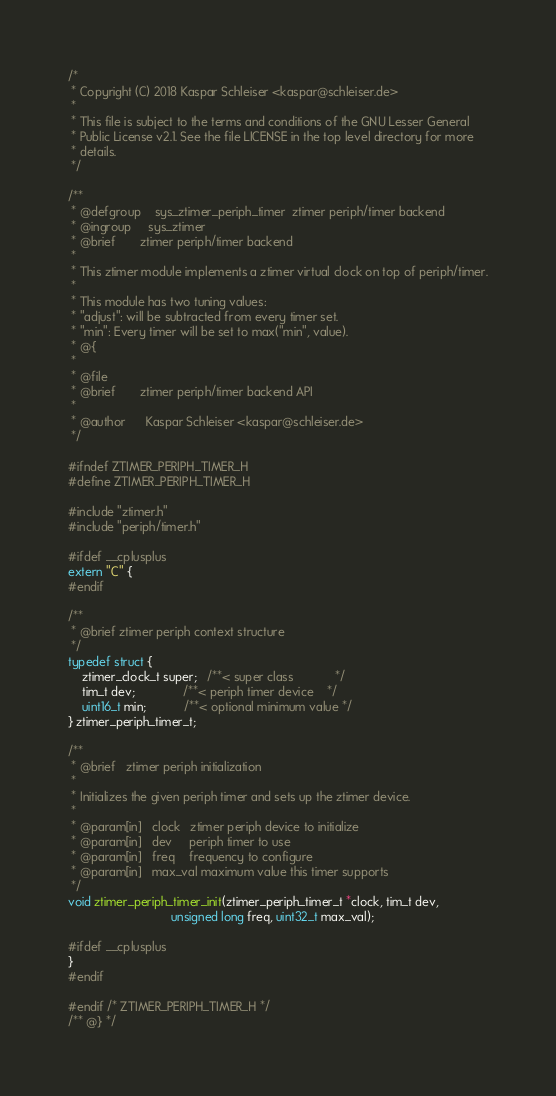<code> <loc_0><loc_0><loc_500><loc_500><_C_>/*
 * Copyright (C) 2018 Kaspar Schleiser <kaspar@schleiser.de>
 *
 * This file is subject to the terms and conditions of the GNU Lesser General
 * Public License v2.1. See the file LICENSE in the top level directory for more
 * details.
 */

/**
 * @defgroup    sys_ztimer_periph_timer  ztimer periph/timer backend
 * @ingroup     sys_ztimer
 * @brief       ztimer periph/timer backend
 *
 * This ztimer module implements a ztimer virtual clock on top of periph/timer.
 *
 * This module has two tuning values:
 * "adjust": will be subtracted from every timer set.
 * "min": Every timer will be set to max("min", value).
 * @{
 *
 * @file
 * @brief       ztimer periph/timer backend API
 *
 * @author      Kaspar Schleiser <kaspar@schleiser.de>
 */

#ifndef ZTIMER_PERIPH_TIMER_H
#define ZTIMER_PERIPH_TIMER_H

#include "ztimer.h"
#include "periph/timer.h"

#ifdef __cplusplus
extern "C" {
#endif

/**
 * @brief ztimer periph context structure
 */
typedef struct {
    ztimer_clock_t super;   /**< super class            */
    tim_t dev;              /**< periph timer device    */
    uint16_t min;           /**< optional minimum value */
} ztimer_periph_timer_t;

/**
 * @brief   ztimer periph initialization
 *
 * Initializes the given periph timer and sets up the ztimer device.
 *
 * @param[in]   clock   ztimer periph device to initialize
 * @param[in]   dev     periph timer to use
 * @param[in]   freq    frequency to configure
 * @param[in]   max_val maximum value this timer supports
 */
void ztimer_periph_timer_init(ztimer_periph_timer_t *clock, tim_t dev,
                              unsigned long freq, uint32_t max_val);

#ifdef __cplusplus
}
#endif

#endif /* ZTIMER_PERIPH_TIMER_H */
/** @} */
</code> 